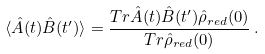Convert formula to latex. <formula><loc_0><loc_0><loc_500><loc_500>\langle \hat { A } ( t ) \hat { B } ( t ^ { \prime } ) \rangle = \frac { T r \hat { A } ( t ) \hat { B } ( t ^ { \prime } ) \hat { \rho } _ { r e d } ( 0 ) } { T r \hat { \rho } _ { r e d } ( 0 ) } \, .</formula> 